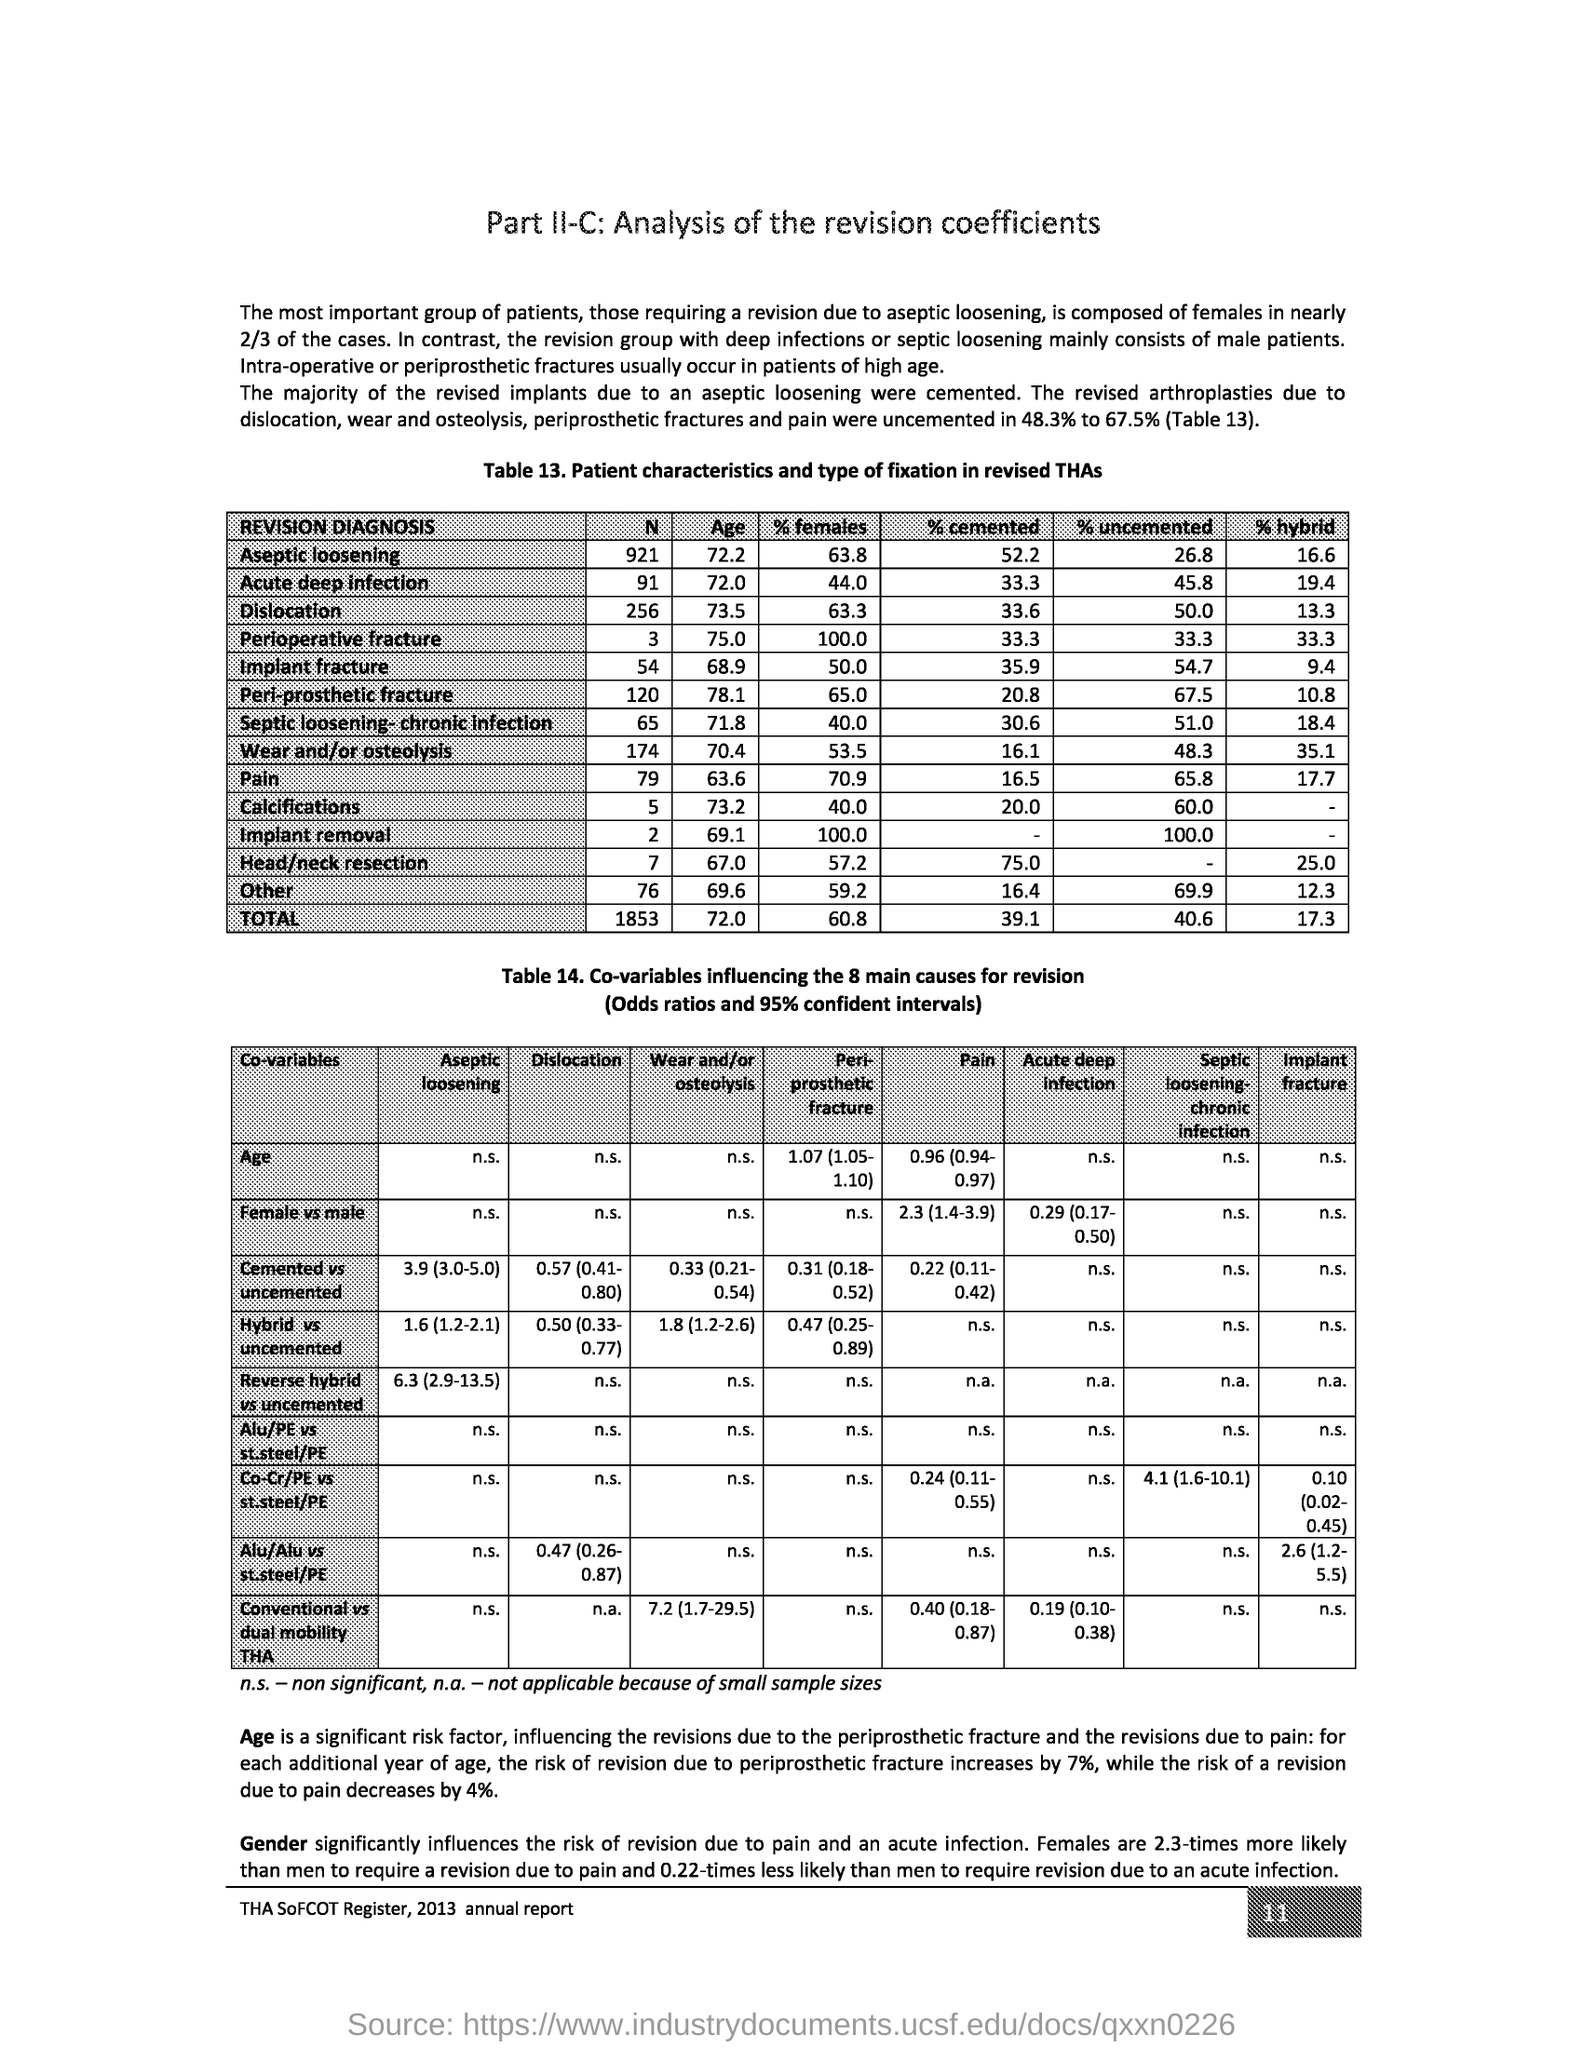Identify some key points in this picture. The page number is 11. 